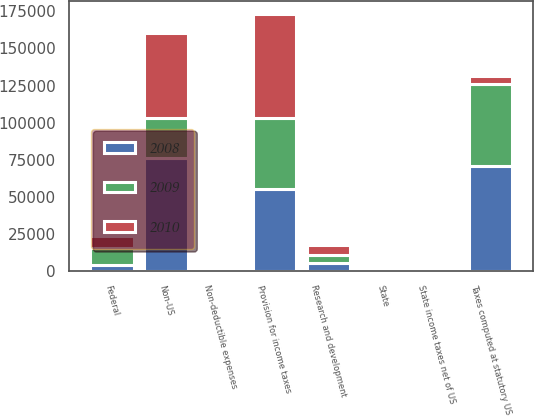Convert chart to OTSL. <chart><loc_0><loc_0><loc_500><loc_500><stacked_bar_chart><ecel><fcel>Federal<fcel>State<fcel>Non-US<fcel>Provision for income taxes<fcel>Taxes computed at statutory US<fcel>State income taxes net of US<fcel>Non-deductible expenses<fcel>Research and development<nl><fcel>2010<fcel>8348<fcel>1561<fcel>57272<fcel>70504<fcel>5646<fcel>886<fcel>594<fcel>6942<nl><fcel>2008<fcel>4129<fcel>1386<fcel>76379<fcel>55236<fcel>70590<fcel>346<fcel>748<fcel>4916<nl><fcel>2009<fcel>11077<fcel>994<fcel>26598<fcel>47552<fcel>55249<fcel>1578<fcel>910<fcel>5646<nl></chart> 